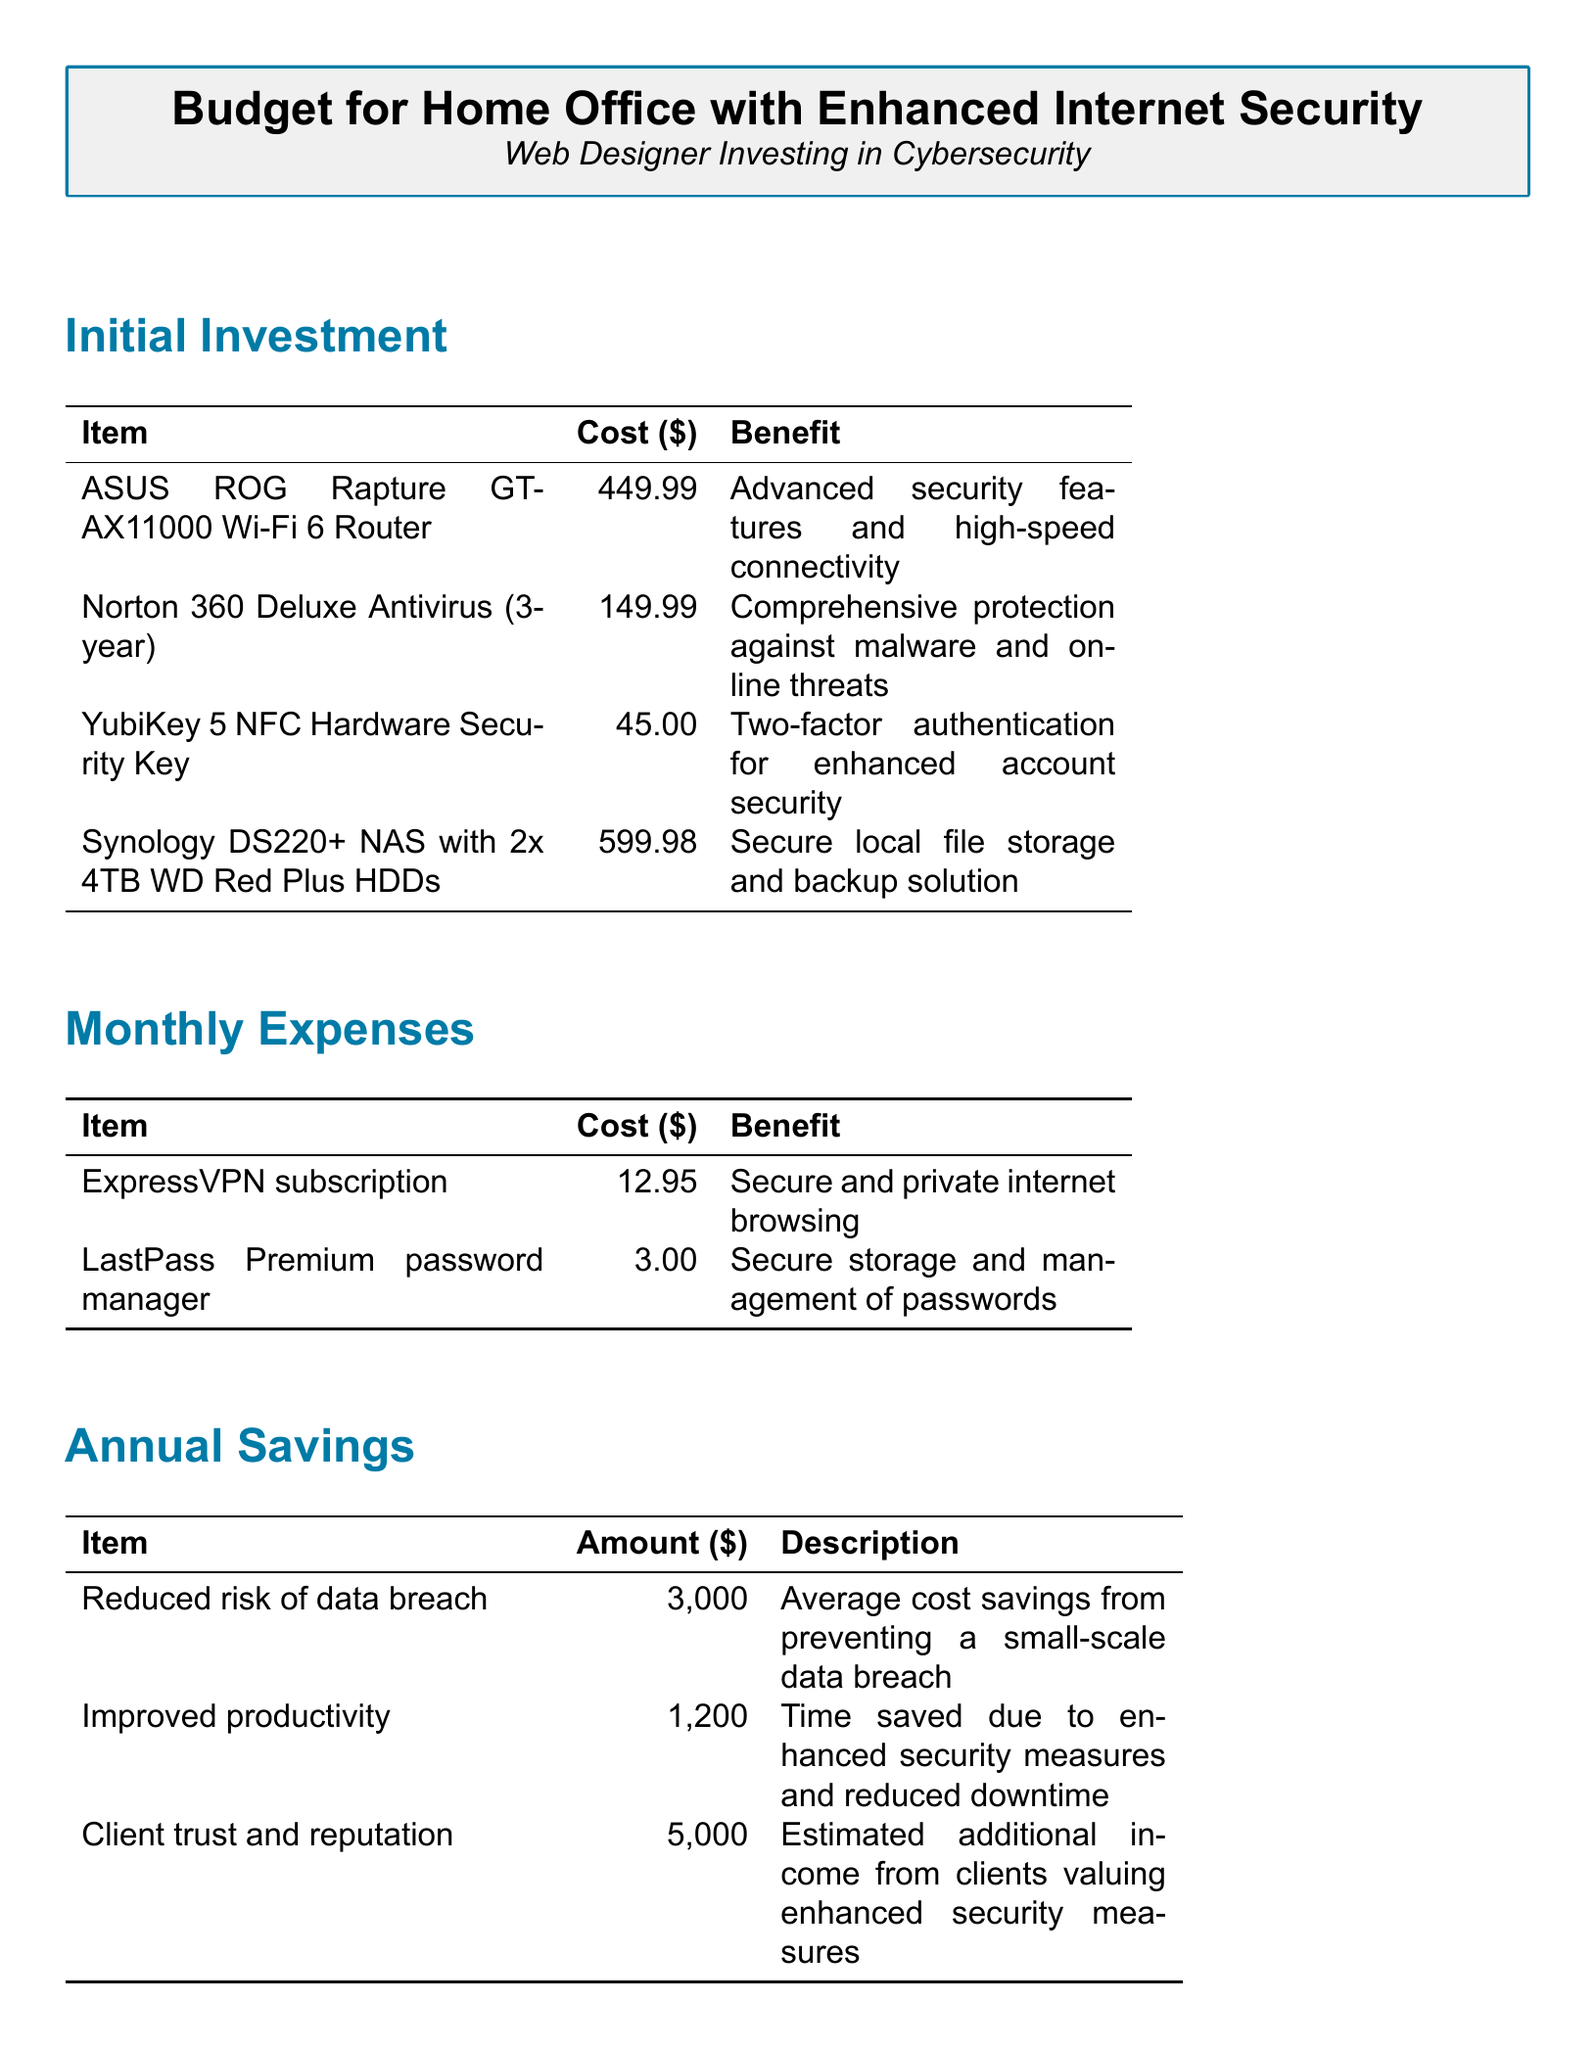What is the total initial investment? The total initial investment is listed in the ROI Calculation section, summing up all the individual costs: $449.99 + $149.99 + $45.00 + $599.98.
Answer: $1,244.96 What is the benefit of the ASUS ROG Rapture GT-AX11000? The benefit listed for the ASUS ROG Rapture GT-AX11000 is "Advanced security features and high-speed connectivity."
Answer: Advanced security features and high-speed connectivity What is the estimated ROI? The estimated ROI can be found in the ROI Calculation section and reflects the returns relative to the investment made.
Answer: 641% How much is the monthly expense for LastPass Premium? The document states the cost for LastPass Premium in the Monthly Expenses table.
Answer: $3.00 What is the annual savings from improved productivity? The amount saved annually from improved productivity is outlined in the Annual Savings section.
Answer: $1,200 What item costs $45.00? The document lists all items and their respective costs; $45.00 corresponds to a specific security feature.
Answer: YubiKey 5 NFC Hardware Security Key How long is the payback period? The payback period for the investment is stated explicitly in the ROI Calculation section of the document.
Answer: 2 months What is the benefit of using ExpressVPN? The benefit is detailed in the Monthly Expenses, highlighting the main advantage of this subscription.
Answer: Secure and private internet browsing What is the total annual savings? The total annual savings are the sum of all listed savings from the Annual Savings section.
Answer: $9,200.00 